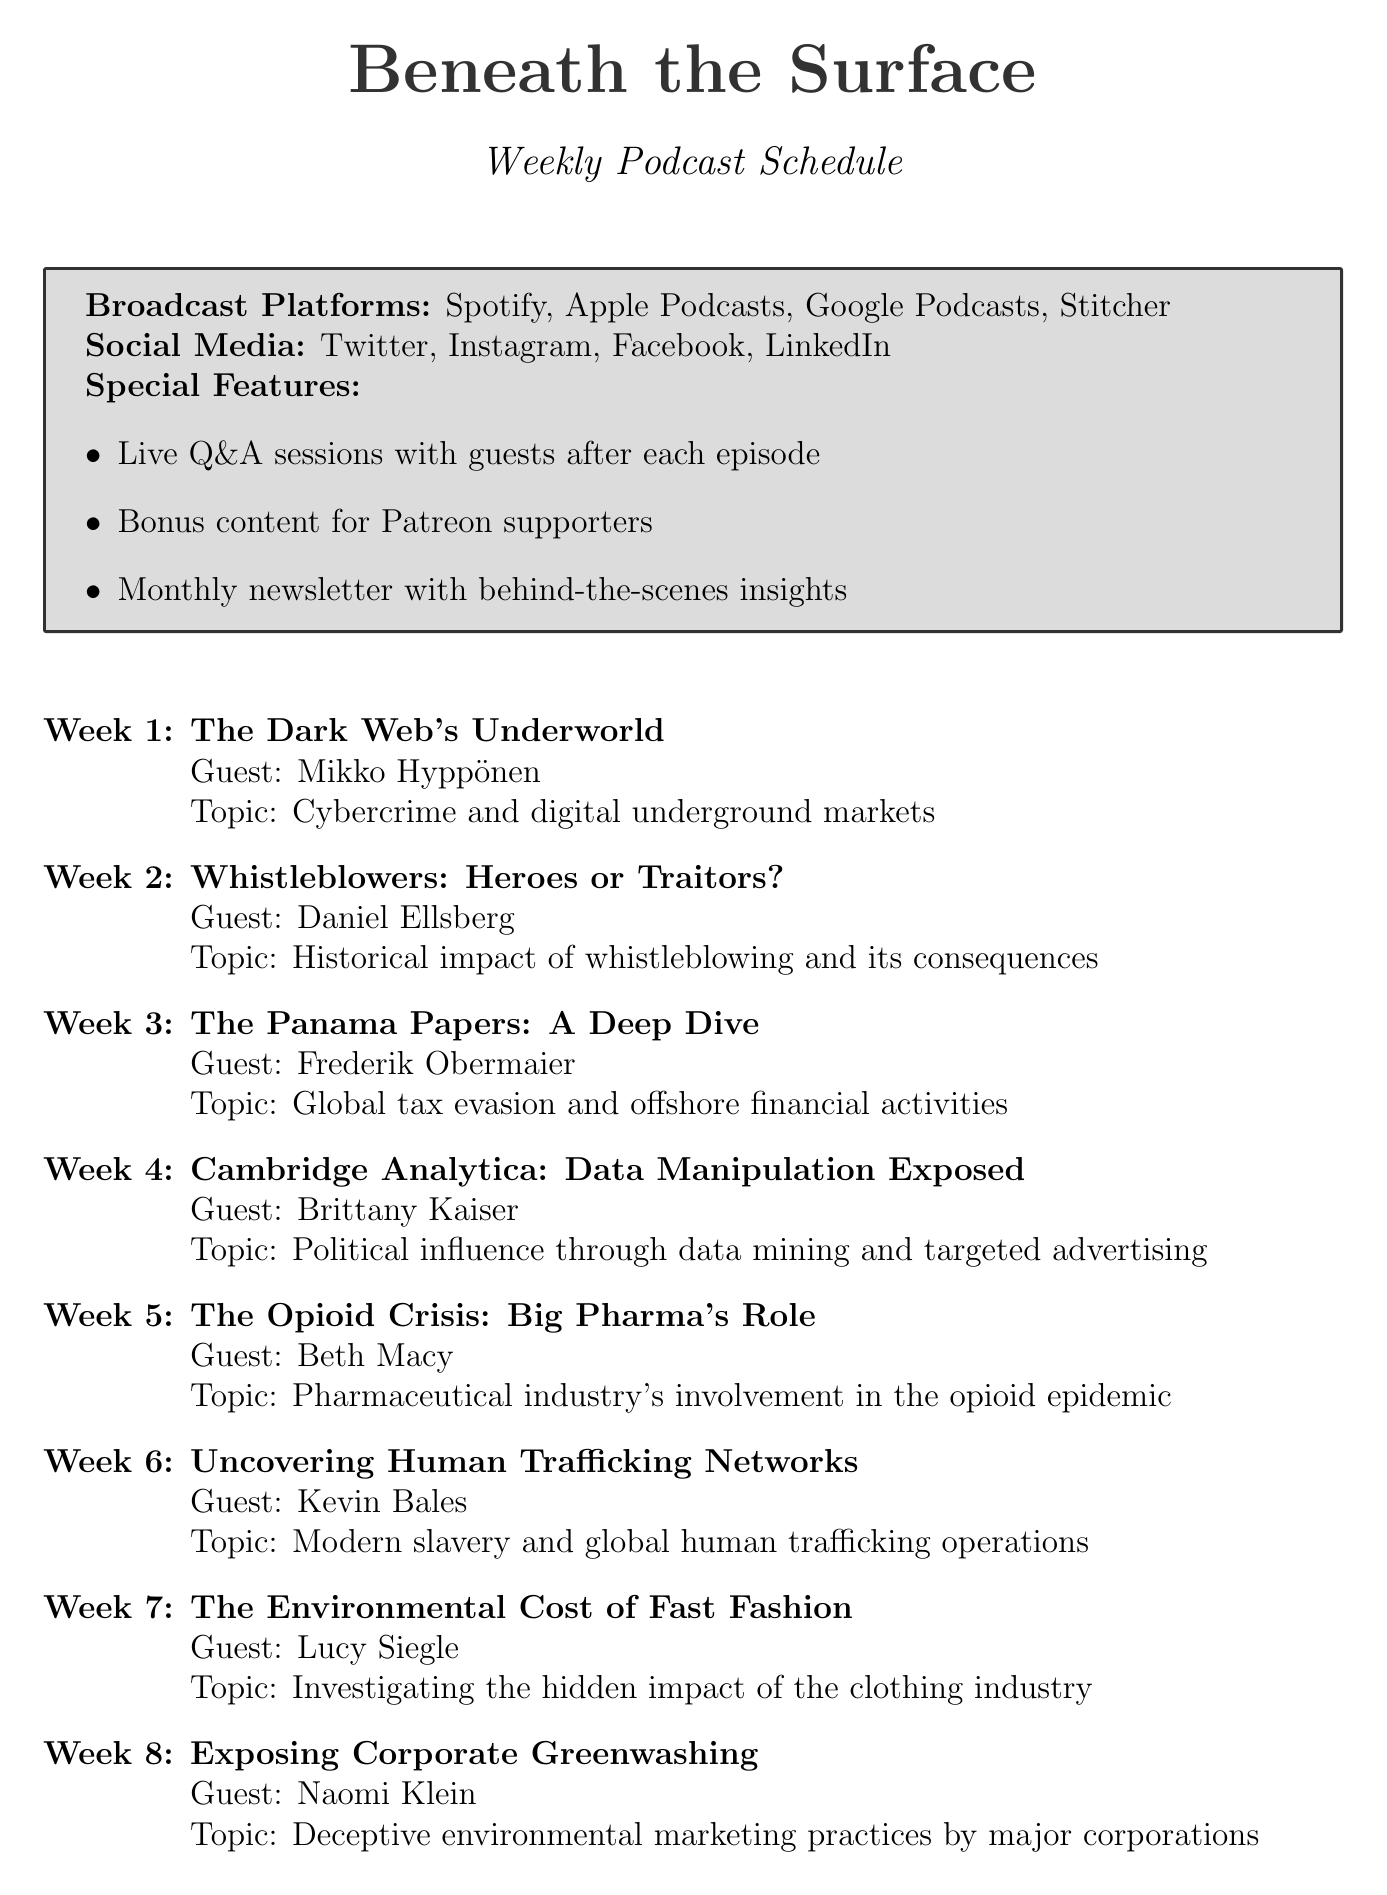what is the name of the podcast? The name of the podcast is provided in the document's title section.
Answer: Beneath the Surface who is the guest speaker for episode 3? The guest speaker for each episode is listed below the episode title in the document.
Answer: Frederik Obermaier what is the topic of the first episode? The topic of each episode is detailed directly under the episode title and guest speaker.
Answer: Cybercrime and digital underground markets how many episodes are there in total? The total number of episodes can be determined by counting the items listed in the weekly schedule.
Answer: 12 which episode covers the opioid crisis? The episode titles are outlined sequentially, allowing identification of the specific episode about the opioid crisis.
Answer: The Opioid Crisis: Big Pharma's Role name one platform where the podcast is available. The broadcast platforms are listed at the beginning of the document.
Answer: Spotify who is the guest speaker for the final episode? The guest speaker for each episode appears directly after the episode title.
Answer: Claire Wardle what is the main topic of the episode featuring Lucy Siegle? The main topic for each episode follows the guest speaker's name and gives insight into the episode's content.
Answer: Investigating the hidden impact of the clothing industry how often do they send out the newsletter? The frequency of the newsletter is mentioned in the special features section of the document.
Answer: Monthly 